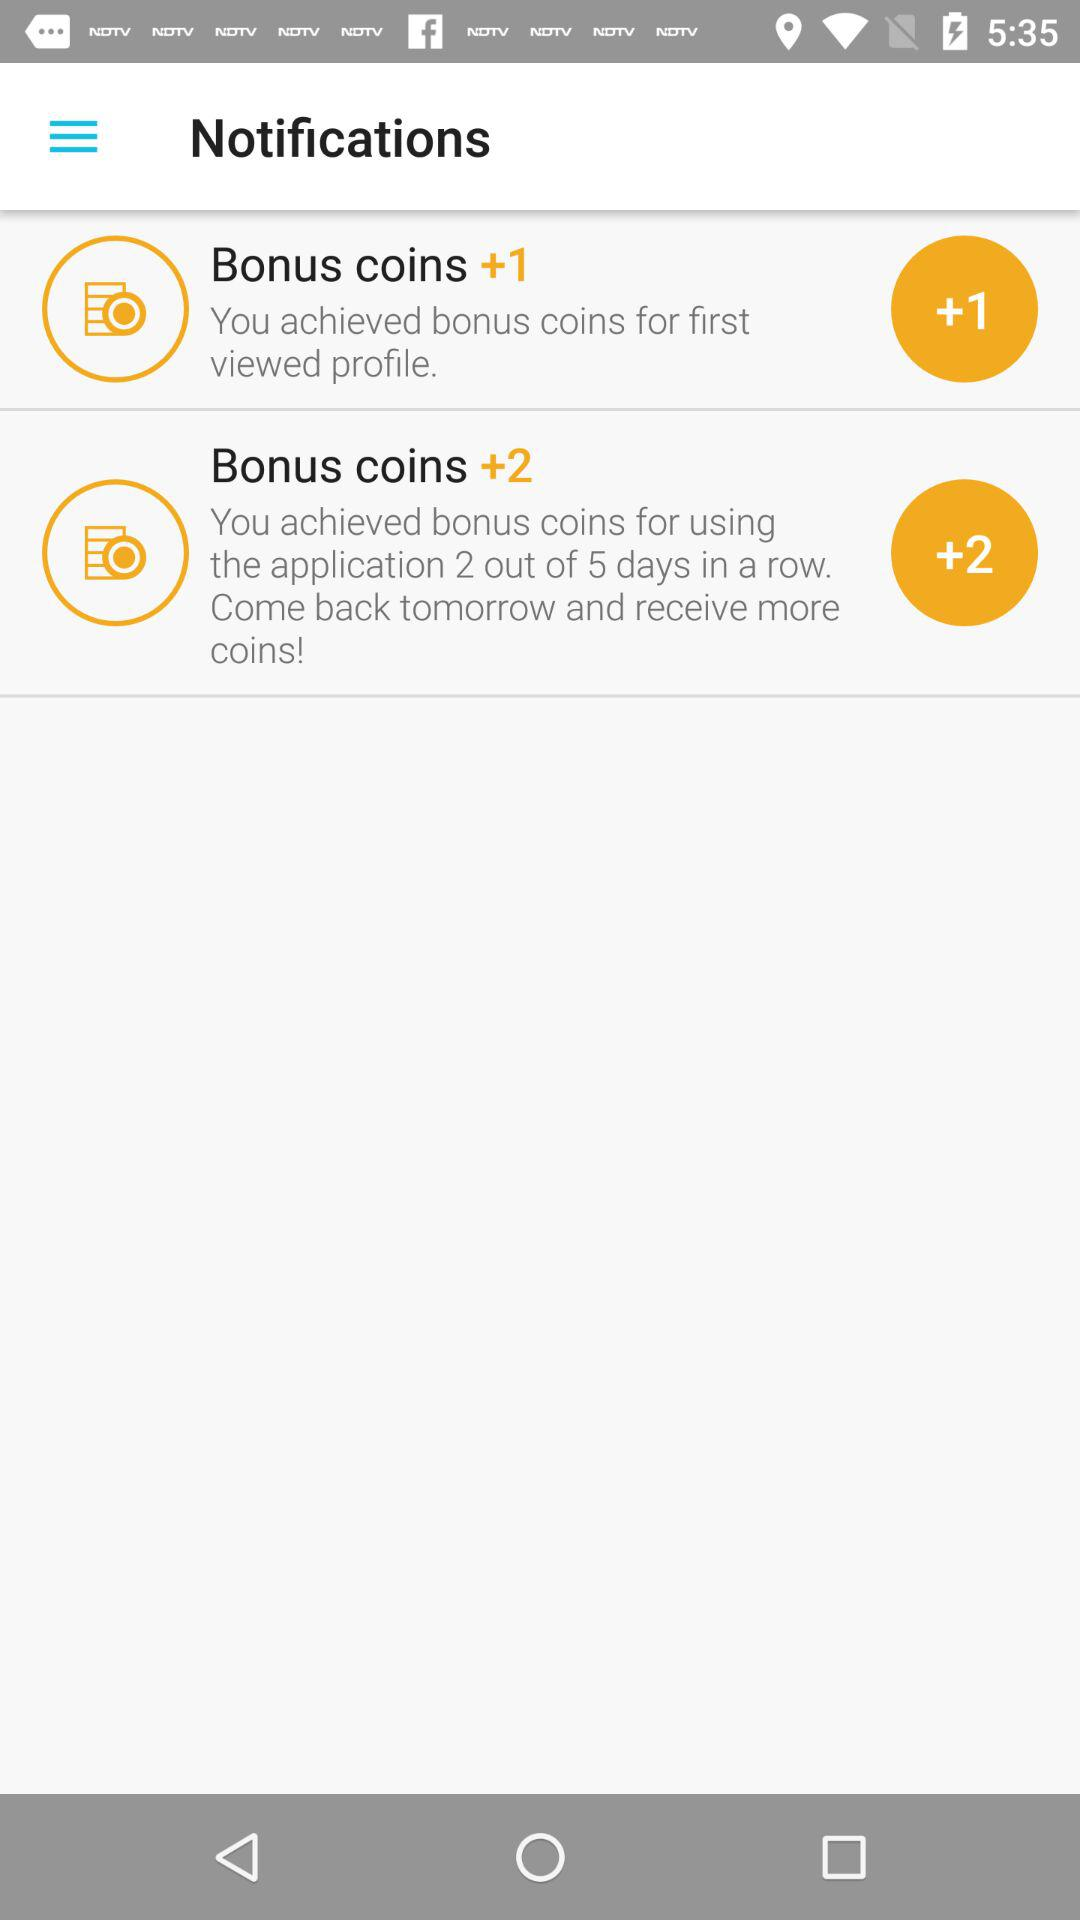How many bonus coins were achieved in total?
Answer the question using a single word or phrase. 3 